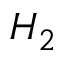Convert formula to latex. <formula><loc_0><loc_0><loc_500><loc_500>H _ { 2 }</formula> 